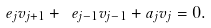<formula> <loc_0><loc_0><loc_500><loc_500>\ e _ { j } v _ { j + 1 } + \ e _ { j - 1 } v _ { j - 1 } + a _ { j } v _ { j } = 0 .</formula> 